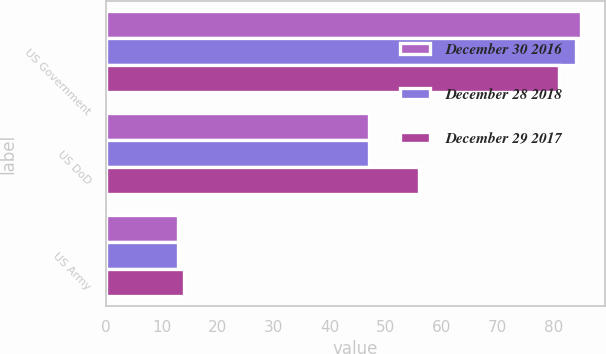Convert chart to OTSL. <chart><loc_0><loc_0><loc_500><loc_500><stacked_bar_chart><ecel><fcel>US Government<fcel>US DoD<fcel>US Army<nl><fcel>December 30 2016<fcel>85<fcel>47<fcel>13<nl><fcel>December 28 2018<fcel>84<fcel>47<fcel>13<nl><fcel>December 29 2017<fcel>81<fcel>56<fcel>14<nl></chart> 